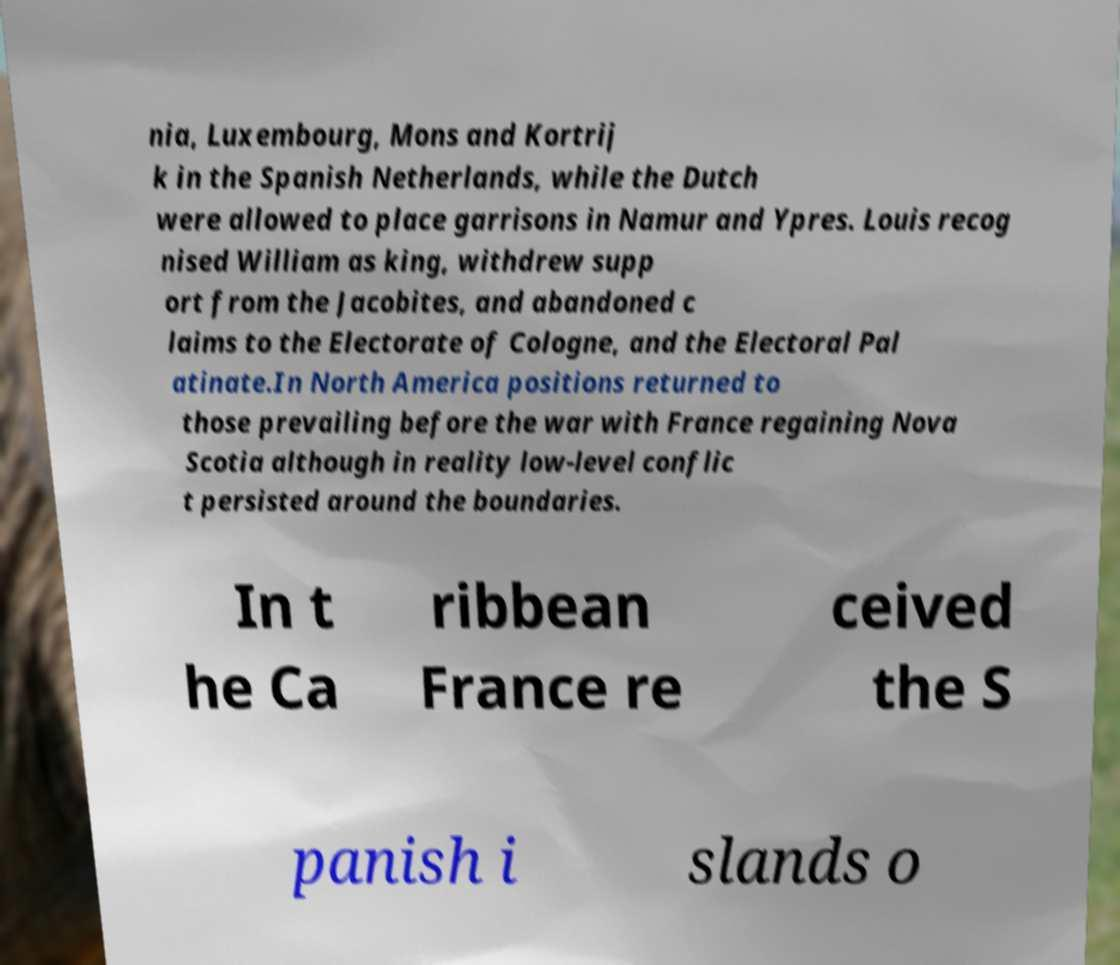There's text embedded in this image that I need extracted. Can you transcribe it verbatim? nia, Luxembourg, Mons and Kortrij k in the Spanish Netherlands, while the Dutch were allowed to place garrisons in Namur and Ypres. Louis recog nised William as king, withdrew supp ort from the Jacobites, and abandoned c laims to the Electorate of Cologne, and the Electoral Pal atinate.In North America positions returned to those prevailing before the war with France regaining Nova Scotia although in reality low-level conflic t persisted around the boundaries. In t he Ca ribbean France re ceived the S panish i slands o 